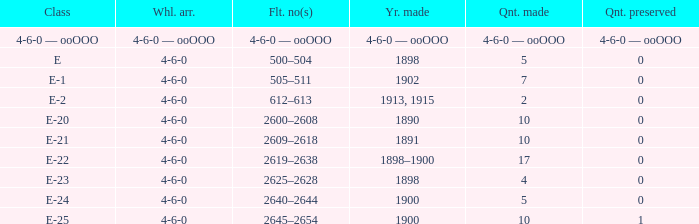How many e-22 class items are made when the preserved quantity is 0? 17.0. 